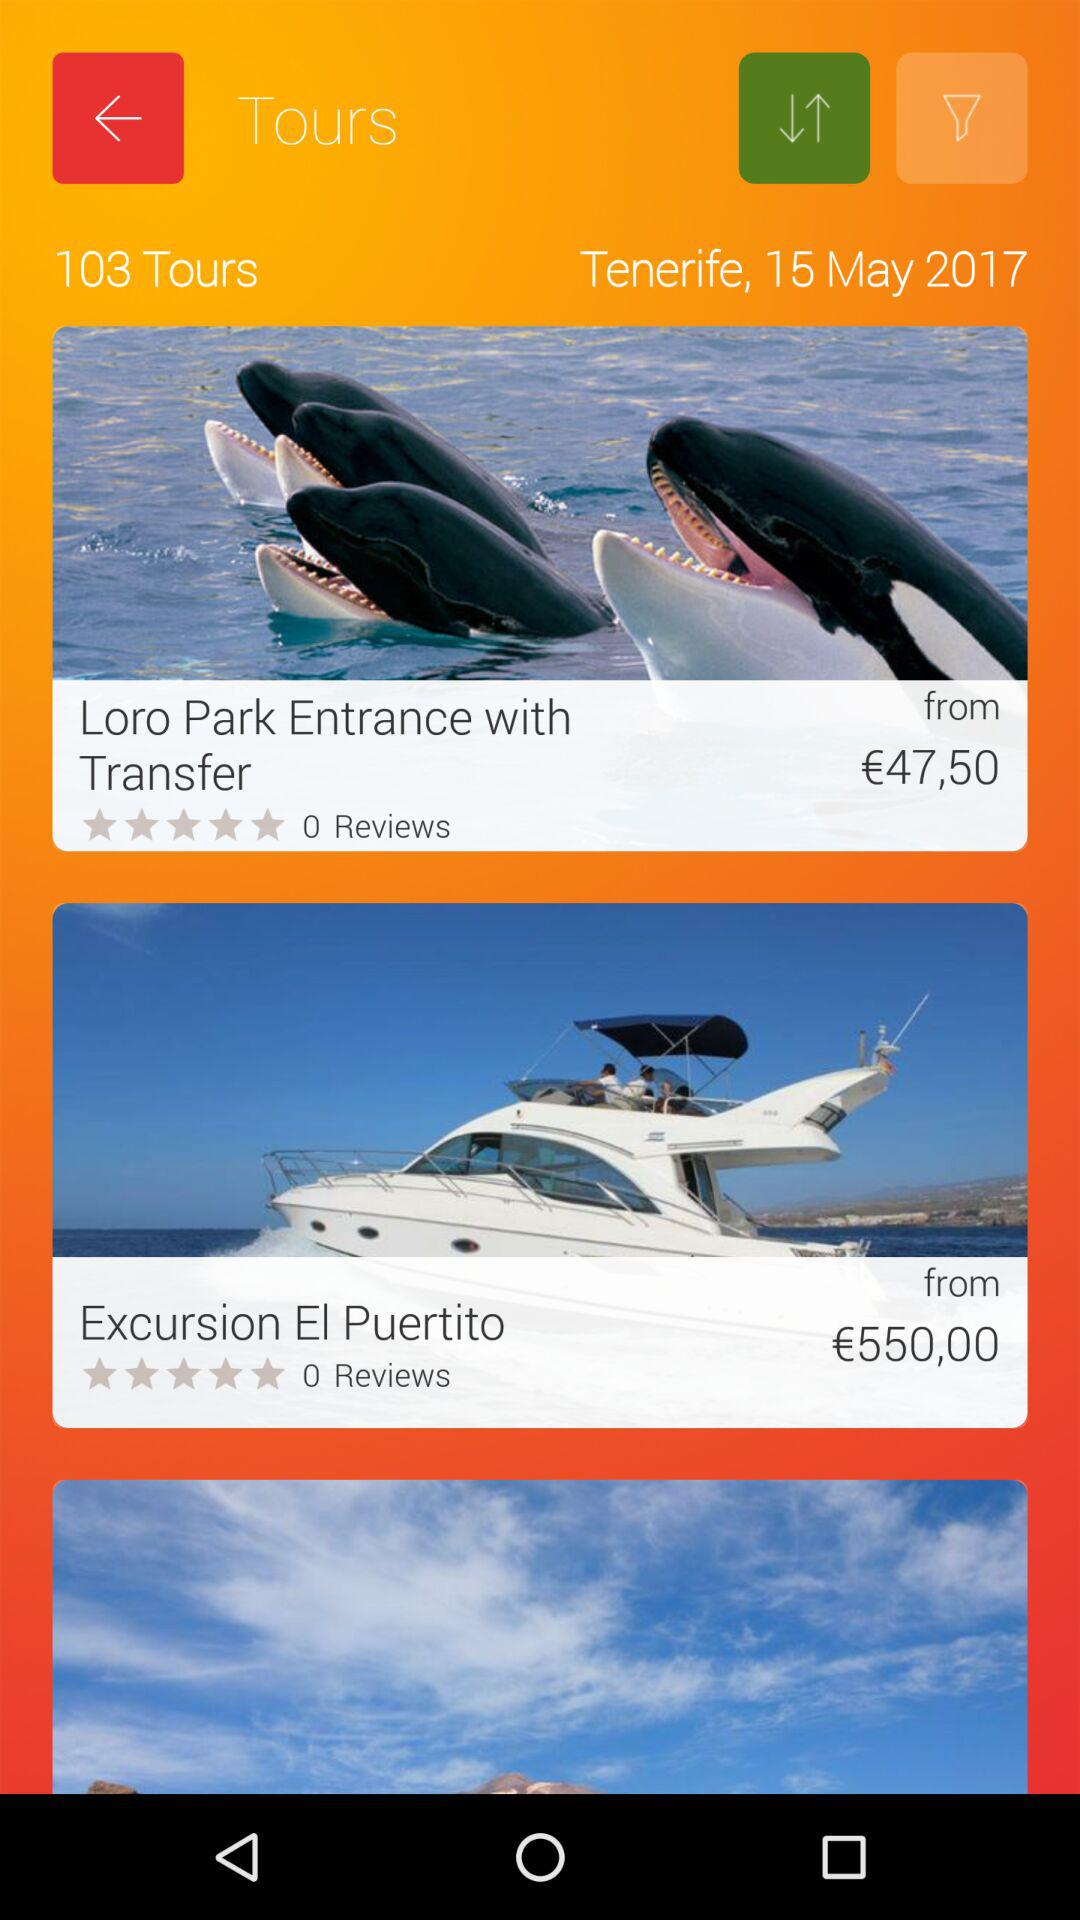How are the results filtered?
When the provided information is insufficient, respond with <no answer>. <no answer> 